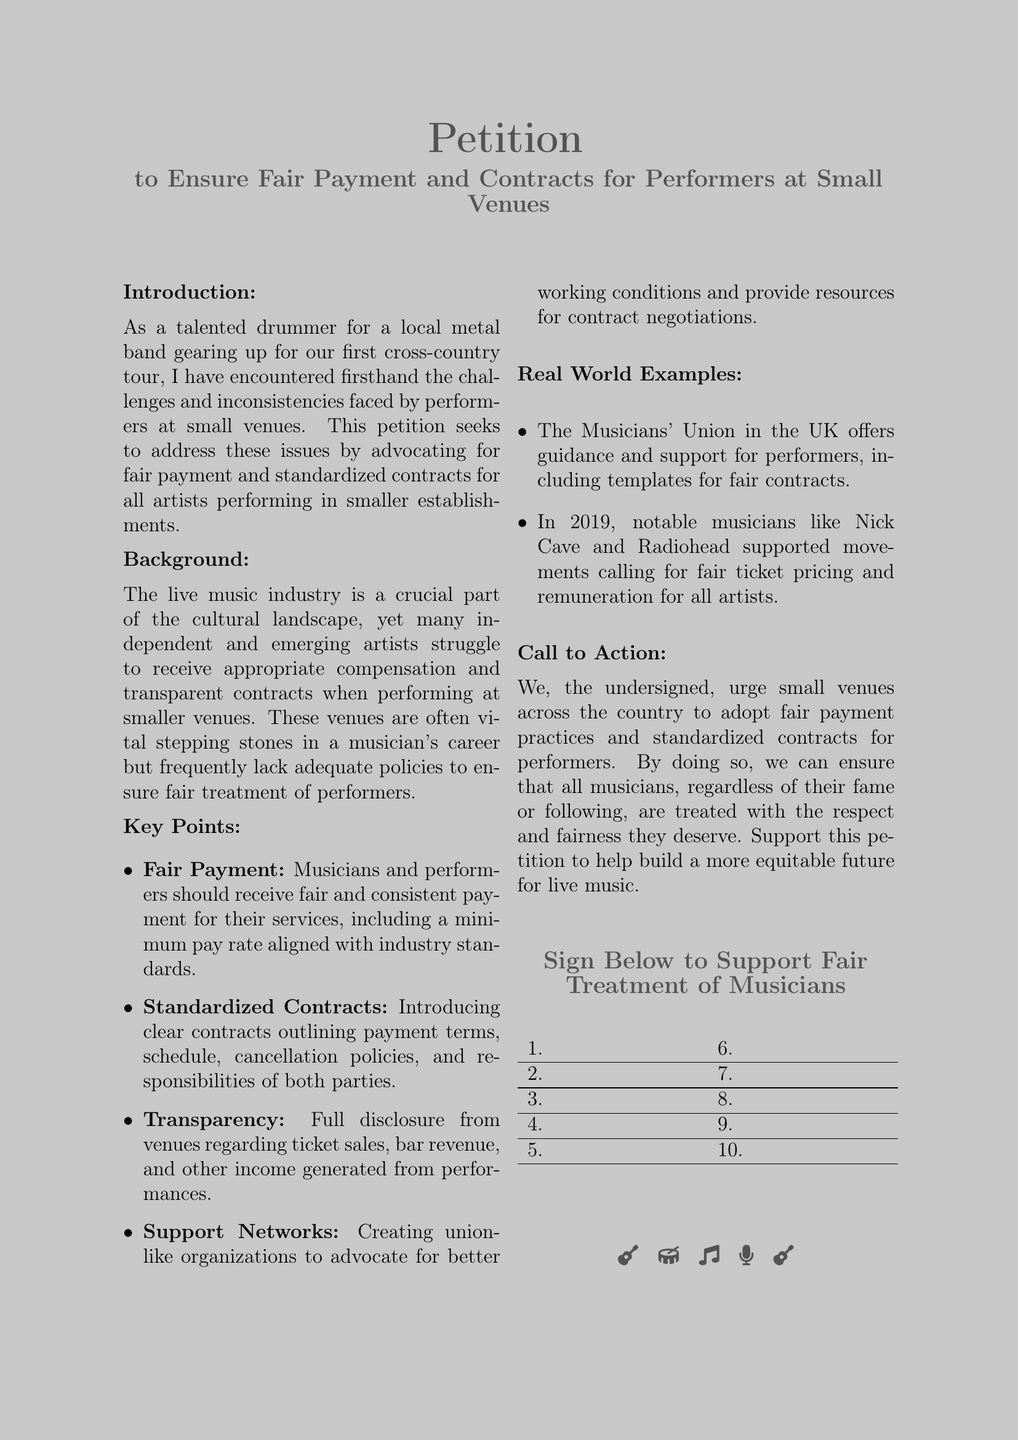What is the title of the petition? The title of the petition is explicitly mentioned at the beginning of the document.
Answer: Petition to Ensure Fair Payment and Contracts for Performers at Small Venues How many key points are listed in the petition? The document outlines a list of key points regarding fair treatment of performers.
Answer: Four Who is the target audience for this petition? The petition calls for action from a specific group, as indicated in the call to action section.
Answer: small venues What organization is mentioned in the real-world examples section? The document provides examples of organizations that support musicians as evidence of the issue.
Answer: Musicians' Union What year did notable musicians support fair ticket pricing? This piece of information is provided in one of the real-world examples to highlight the movement's relevance.
Answer: 2019 What is the purpose of the petition? The overall goal of the petition is explicitly stated in the introduction section.
Answer: Ensure fair payment and standardized contracts How are musicians encouraged to unite for better conditions? The key points suggest a specific kind of organization that can support musicians.
Answer: union-like organizations What are performers urged to receive according to the petition? The document emphasizes a specific treatment that performers should experience for their services.
Answer: fair and consistent payment 